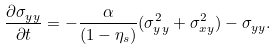Convert formula to latex. <formula><loc_0><loc_0><loc_500><loc_500>\frac { \partial \sigma _ { y y } } { \partial t } = - \frac { \alpha } { ( 1 - \eta _ { s } ) } ( \sigma _ { y y } ^ { 2 } + \sigma _ { x y } ^ { 2 } ) - \sigma _ { y y } .</formula> 